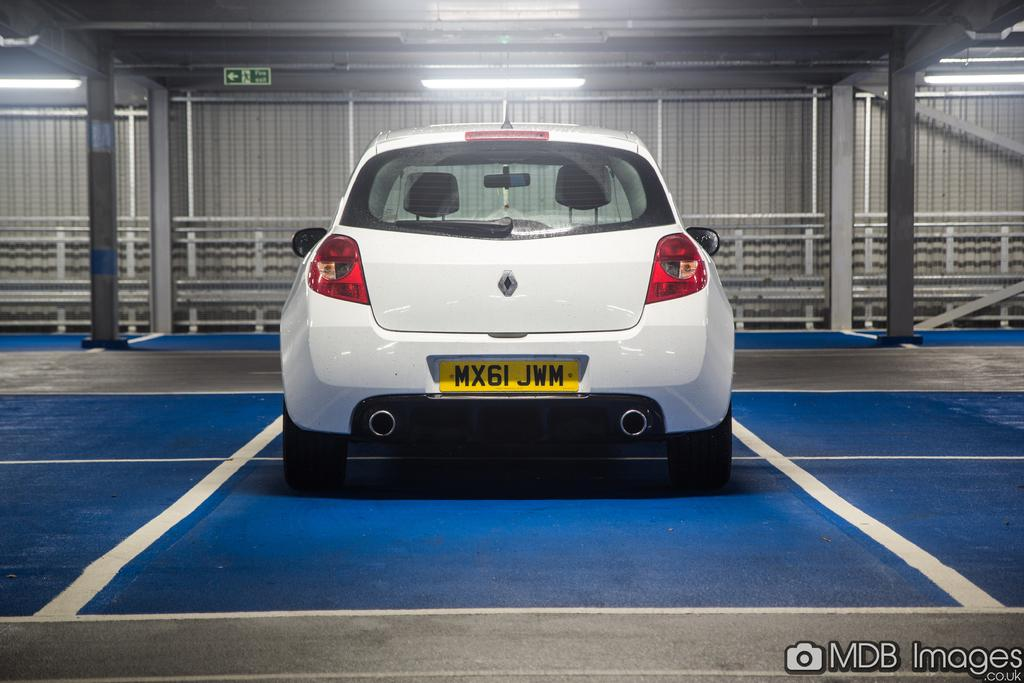What is located on the ground in the image? There is a car on the ground in the image. What architectural features can be seen in the image? There are pillars in the image. What type of informational or directional object is present in the image? There is a sign board in the image. What type of lighting is present in the image? There are lights on the ceiling in the image. What can be seen in the background of the image? There is a fence in the background of the image. What type of knot is being tied by the car in the image? There is no knot being tied by the car in the image, as cars do not have the ability to tie knots. 